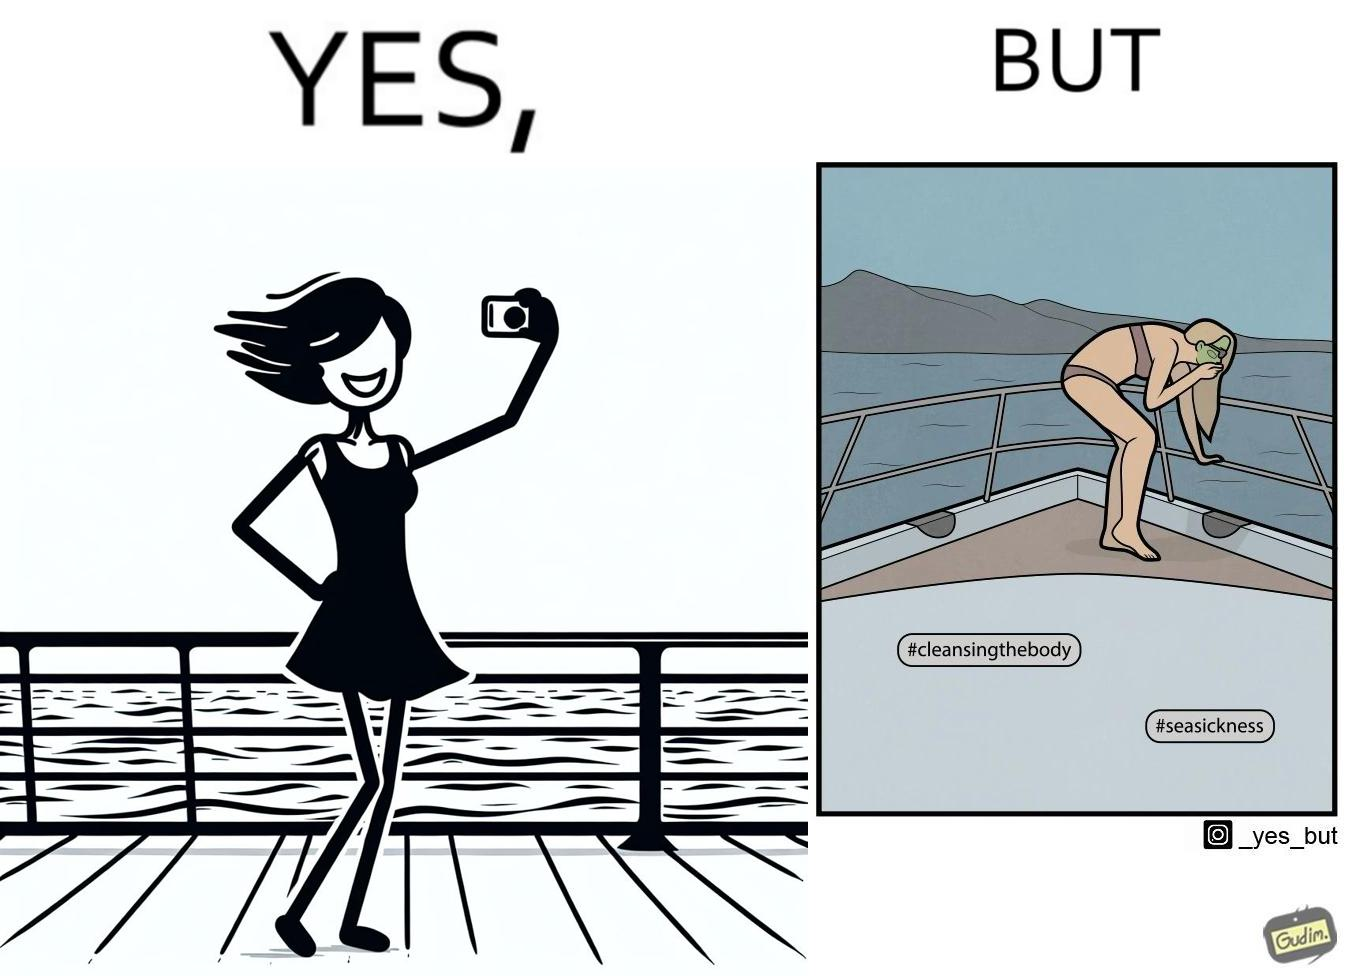What makes this image funny or satirical? The image is ironic, because in the first image the woman is showing how she is enjoying the sea trip but whereas the second image shows how she is struggling over the trip due to sea sickness which brings up a contrast comparison between the two photos 